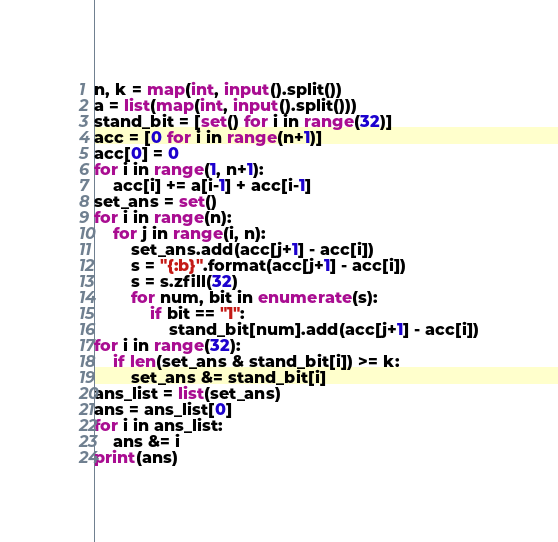Convert code to text. <code><loc_0><loc_0><loc_500><loc_500><_Python_>n, k = map(int, input().split())
a = list(map(int, input().split()))
stand_bit = [set() for i in range(32)]
acc = [0 for i in range(n+1)]
acc[0] = 0
for i in range(1, n+1):
    acc[i] += a[i-1] + acc[i-1]
set_ans = set()
for i in range(n):
    for j in range(i, n):
        set_ans.add(acc[j+1] - acc[i])
        s = "{:b}".format(acc[j+1] - acc[i])
        s = s.zfill(32)
        for num, bit in enumerate(s):
            if bit == "1":
                stand_bit[num].add(acc[j+1] - acc[i])
for i in range(32):
    if len(set_ans & stand_bit[i]) >= k:
        set_ans &= stand_bit[i]
ans_list = list(set_ans)
ans = ans_list[0]
for i in ans_list:
    ans &= i
print(ans)

</code> 